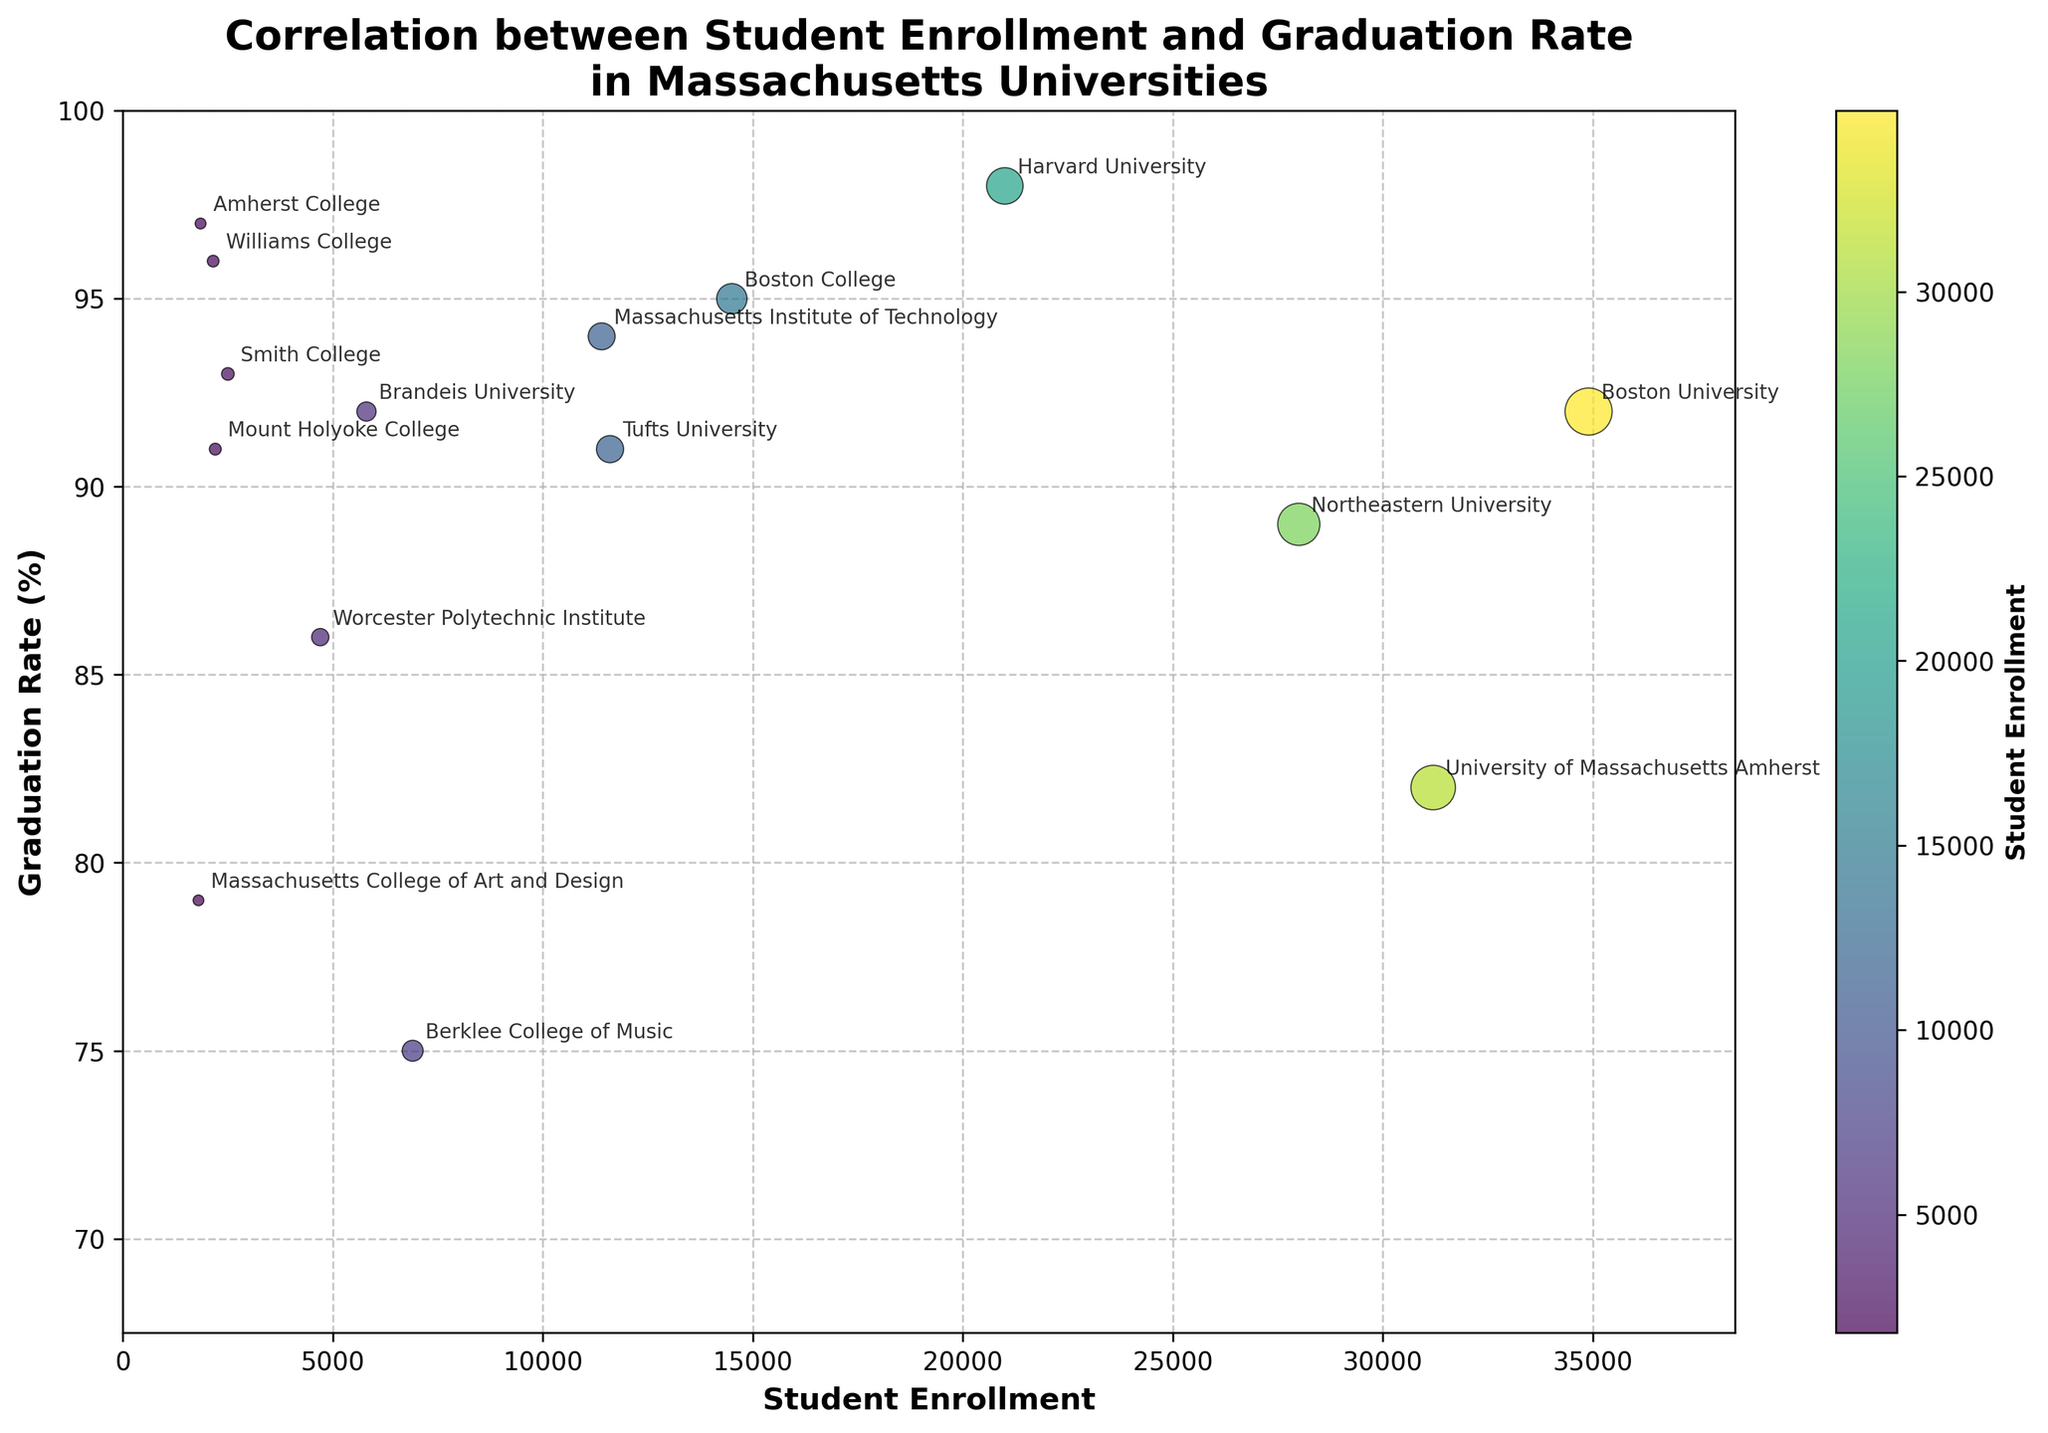What is the title of the figure? The title of the figure is located at the top and directly states what the visual represents.
Answer: Correlation between Student Enrollment and Graduation Rate in Massachusetts Universities What are the labels on the x-axis and y-axis? The x-axis and y-axis labels are found directly beside the respective axes. The x-axis label is "Student Enrollment" and the y-axis label is "Graduation Rate (%)".
Answer: Student Enrollment and Graduation Rate (%) Which university has the highest student enrollment? By checking the data points and annotations, we can find the one with the highest x-axis value, which indicates student enrollment.
Answer: Boston University What is the approximate graduation rate of Harvard University? Harvard University's graduation rate can be found by locating the data point annotated with "Harvard University" and observing its y-axis value.
Answer: 98% How does the graduation rate of Massachusetts College of Art and Design compare to Berklee College of Music? Locate the data points for both universities and compare their y-axis values. Massachusetts College of Art and Design has a graduation rate of 79%, and Berklee College of Music has a graduation rate of 75%.
Answer: Higher Which universities have a graduation rate of over 90%? Identify the data points with a y-axis value greater than 90% and check their annotations. These universities include Harvard University, Massachusetts Institute of Technology, Tufts University, Boston College, Amherst College, Williams College, Smith College, and Mount Holyoke College.
Answer: 8 universities What is the range of student enrollments among the universities? The range is found by subtracting the smallest student enrollment from the largest one. The smallest enrollment is 1,800 (Massachusetts College of Art and Design), and the largest is 34,900 (Boston University). The range is 34,900 - 1,800.
Answer: 33,100 Do universities with smaller enrollments tend to have higher graduation rates? Observe the trend of data points. Universities on the left (representing smaller enrollments) mostly have high y-axis values, indicating higher graduation rates. Most universities like Amherst College, Williams College, and others with smaller enrollments (below 3,000) have graduation rates above 90%.
Answer: Yes In comparison to the colorbar, which university has the lowest enrollment? By examining the colorbar mapping and data points, we notice Massachusetts College of Art and Design having the darkest color, implying the lowest student enrollment.
Answer: Massachusetts College of Art and Design What observation can be made about student enrollments between Boston University and Northeastern University? Compare the x-axis values of data points for both universities. Boston University has a higher student enrollment (34,900) compared to Northeastern University (28,000).
Answer: Boston University has higher enrollment 